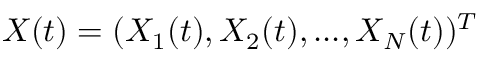Convert formula to latex. <formula><loc_0><loc_0><loc_500><loc_500>X ( t ) = ( X _ { 1 } ( t ) , X _ { 2 } ( t ) , \dots , X _ { N } ( t ) ) ^ { T }</formula> 